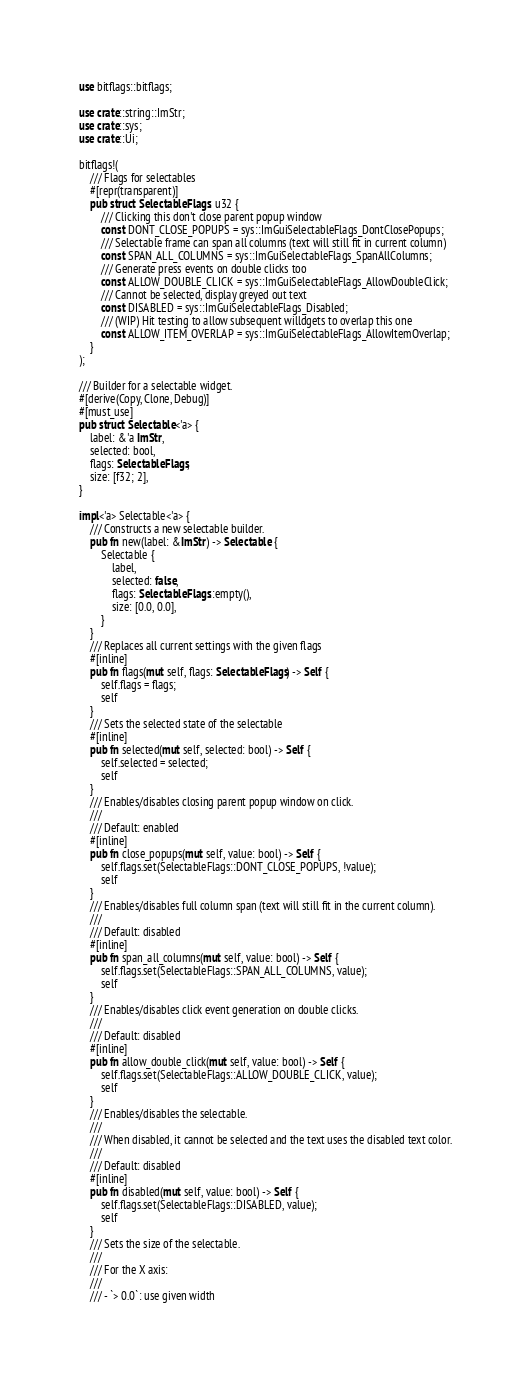<code> <loc_0><loc_0><loc_500><loc_500><_Rust_>use bitflags::bitflags;

use crate::string::ImStr;
use crate::sys;
use crate::Ui;

bitflags!(
    /// Flags for selectables
    #[repr(transparent)]
    pub struct SelectableFlags: u32 {
        /// Clicking this don't close parent popup window
        const DONT_CLOSE_POPUPS = sys::ImGuiSelectableFlags_DontClosePopups;
        /// Selectable frame can span all columns (text will still fit in current column)
        const SPAN_ALL_COLUMNS = sys::ImGuiSelectableFlags_SpanAllColumns;
        /// Generate press events on double clicks too
        const ALLOW_DOUBLE_CLICK = sys::ImGuiSelectableFlags_AllowDoubleClick;
        /// Cannot be selected, display greyed out text
        const DISABLED = sys::ImGuiSelectableFlags_Disabled;
        /// (WIP) Hit testing to allow subsequent willdgets to overlap this one
        const ALLOW_ITEM_OVERLAP = sys::ImGuiSelectableFlags_AllowItemOverlap;
    }
);

/// Builder for a selectable widget.
#[derive(Copy, Clone, Debug)]
#[must_use]
pub struct Selectable<'a> {
    label: &'a ImStr,
    selected: bool,
    flags: SelectableFlags,
    size: [f32; 2],
}

impl<'a> Selectable<'a> {
    /// Constructs a new selectable builder.
    pub fn new(label: &ImStr) -> Selectable {
        Selectable {
            label,
            selected: false,
            flags: SelectableFlags::empty(),
            size: [0.0, 0.0],
        }
    }
    /// Replaces all current settings with the given flags
    #[inline]
    pub fn flags(mut self, flags: SelectableFlags) -> Self {
        self.flags = flags;
        self
    }
    /// Sets the selected state of the selectable
    #[inline]
    pub fn selected(mut self, selected: bool) -> Self {
        self.selected = selected;
        self
    }
    /// Enables/disables closing parent popup window on click.
    ///
    /// Default: enabled
    #[inline]
    pub fn close_popups(mut self, value: bool) -> Self {
        self.flags.set(SelectableFlags::DONT_CLOSE_POPUPS, !value);
        self
    }
    /// Enables/disables full column span (text will still fit in the current column).
    ///
    /// Default: disabled
    #[inline]
    pub fn span_all_columns(mut self, value: bool) -> Self {
        self.flags.set(SelectableFlags::SPAN_ALL_COLUMNS, value);
        self
    }
    /// Enables/disables click event generation on double clicks.
    ///
    /// Default: disabled
    #[inline]
    pub fn allow_double_click(mut self, value: bool) -> Self {
        self.flags.set(SelectableFlags::ALLOW_DOUBLE_CLICK, value);
        self
    }
    /// Enables/disables the selectable.
    ///
    /// When disabled, it cannot be selected and the text uses the disabled text color.
    ///
    /// Default: disabled
    #[inline]
    pub fn disabled(mut self, value: bool) -> Self {
        self.flags.set(SelectableFlags::DISABLED, value);
        self
    }
    /// Sets the size of the selectable.
    ///
    /// For the X axis:
    ///
    /// - `> 0.0`: use given width</code> 